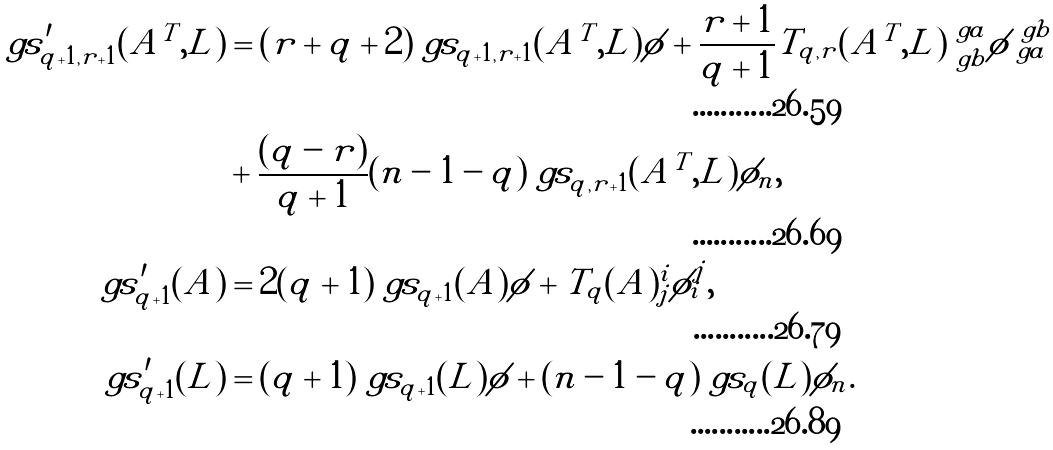Convert formula to latex. <formula><loc_0><loc_0><loc_500><loc_500>\ g s ^ { \prime } _ { q + 1 , r + 1 } ( A ^ { T } , L ) & = ( r + q + 2 ) \ g s _ { q + 1 , r + 1 } ( A ^ { T } , L ) \phi + \frac { r + 1 } { q + 1 } T _ { q , r } ( A ^ { T } , L ) ^ { \ g a } _ { \ g b } \phi ^ { \ g b } _ { \ g a } \\ & + \frac { ( q - r ) } { q + 1 } ( n - 1 - q ) \ g s _ { q , r + 1 } ( A ^ { T } , L ) \phi _ { n } , \\ \ g s ^ { \prime } _ { q + 1 } ( A ) & = 2 ( q + 1 ) \ g s _ { q + 1 } ( A ) \phi + T _ { q } ( A ) ^ { i } _ { j } \phi ^ { j } _ { i } , \\ \ g s ^ { \prime } _ { q + 1 } ( L ) & = ( q + 1 ) \ g s _ { q + 1 } ( L ) \phi + ( n - 1 - q ) \ g s _ { q } ( L ) \phi _ { n } .</formula> 